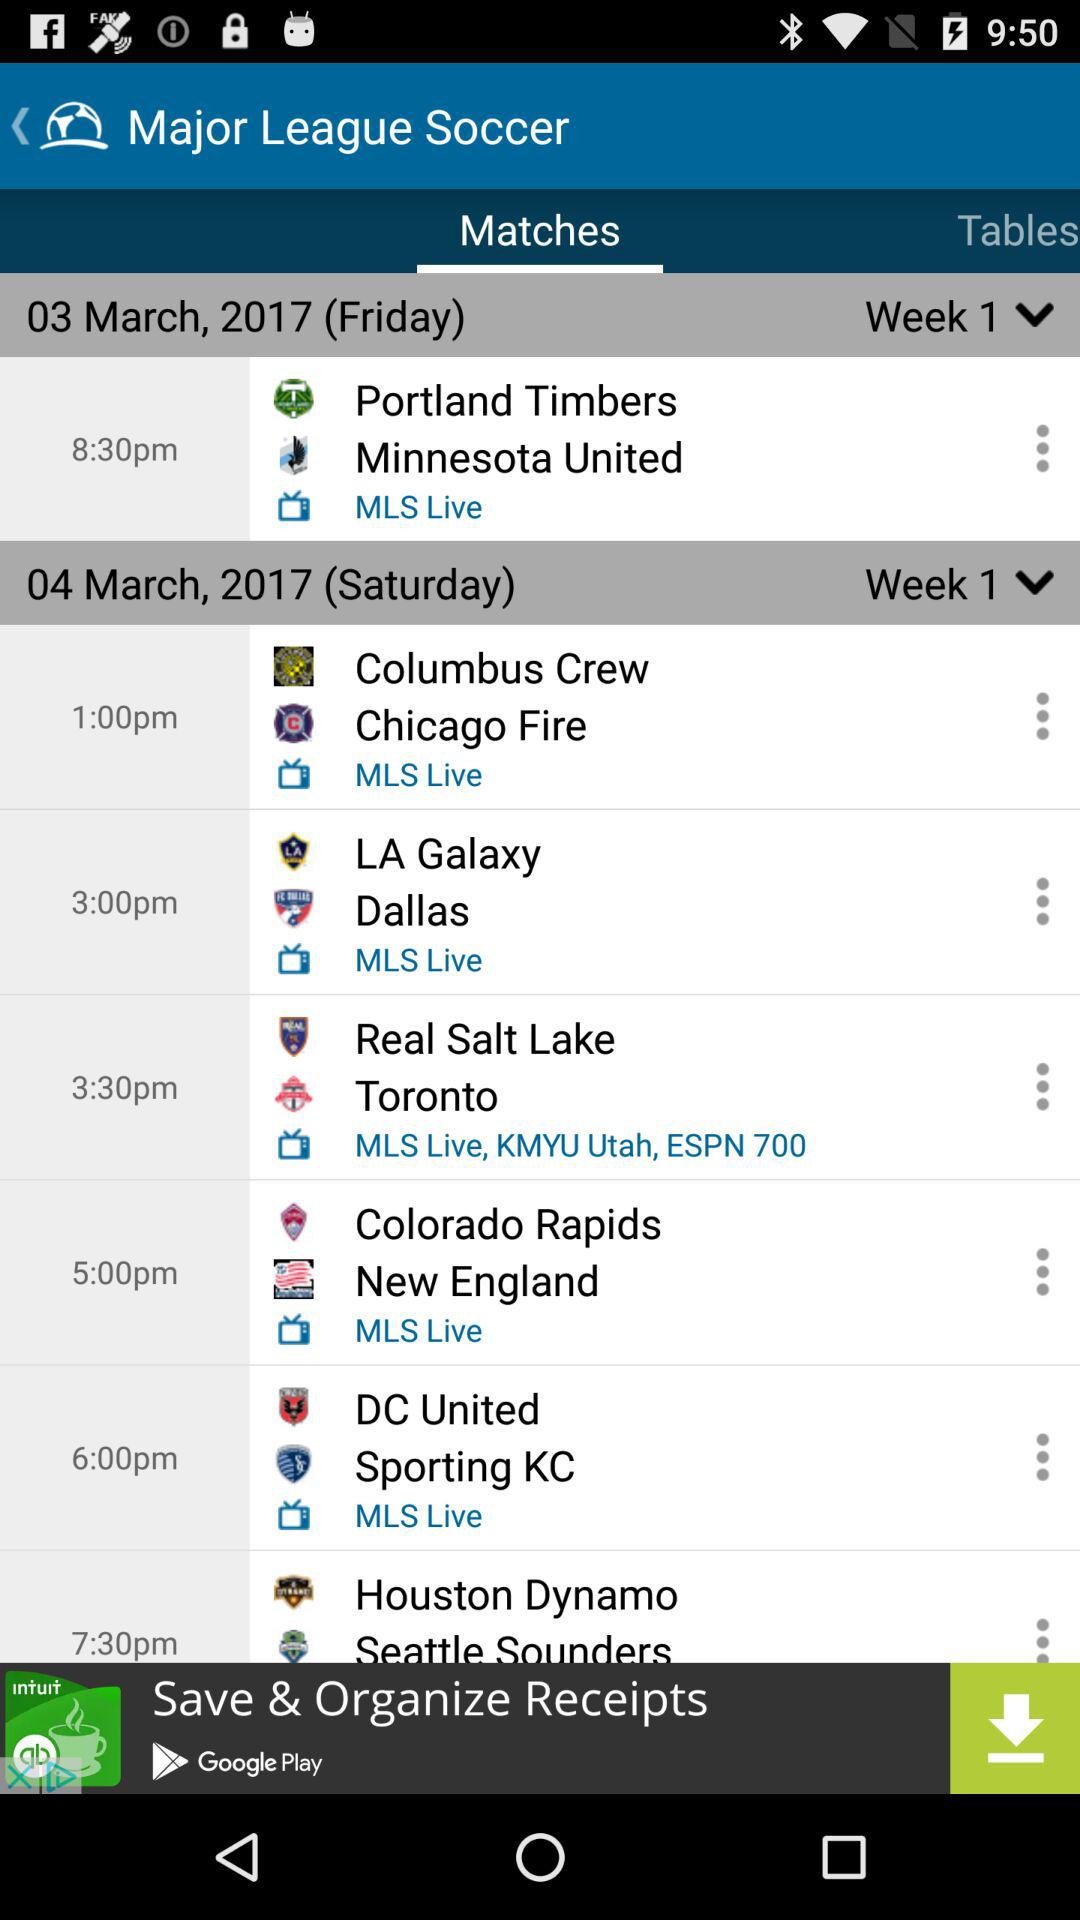How many matches are scheduled for Saturday?
Answer the question using a single word or phrase. 6 